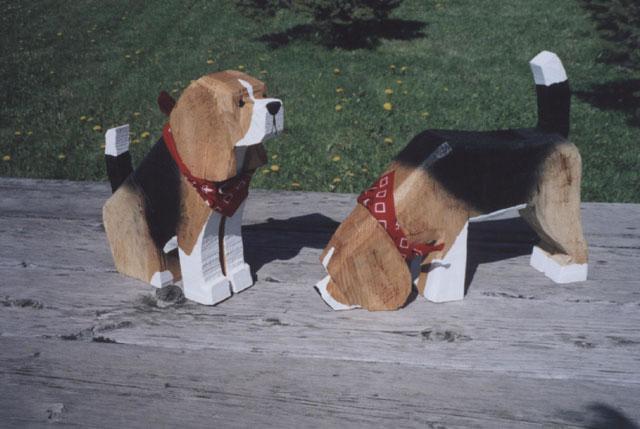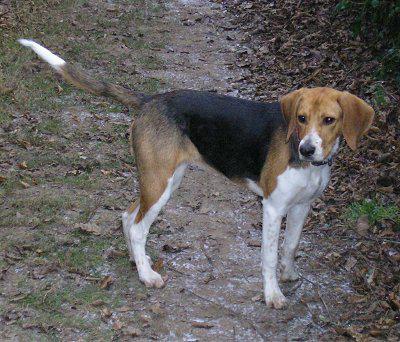The first image is the image on the left, the second image is the image on the right. For the images shown, is this caption "There are two dog figurines on the left." true? Answer yes or no. Yes. 